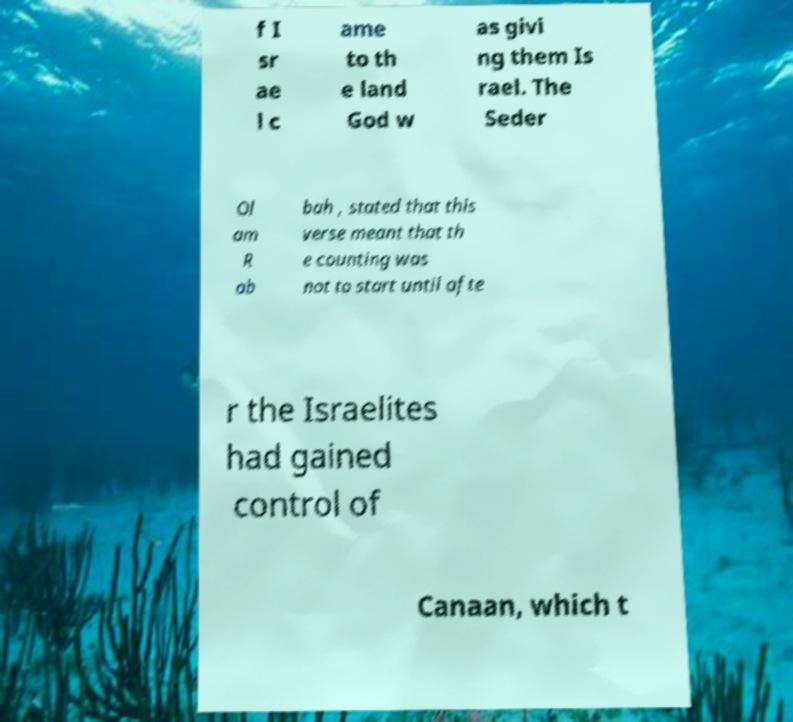There's text embedded in this image that I need extracted. Can you transcribe it verbatim? f I sr ae l c ame to th e land God w as givi ng them Is rael. The Seder Ol am R ab bah , stated that this verse meant that th e counting was not to start until afte r the Israelites had gained control of Canaan, which t 